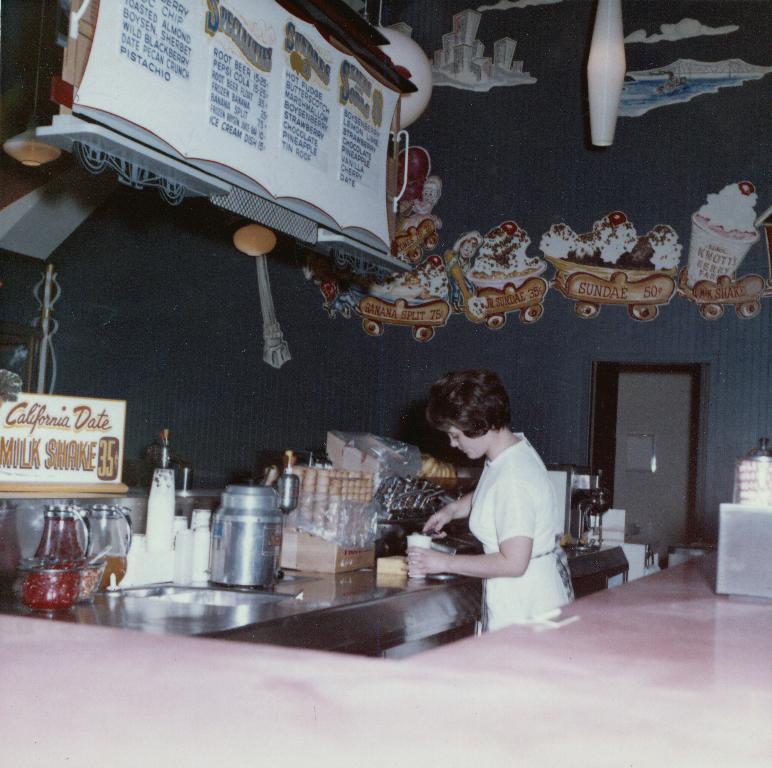Could you give a brief overview of what you see in this image? In the picture there is a woman making ice cream,there is an ice cream machine,ice cream cones and flavor jar above there is a cloth and left side corner there is a menu. 